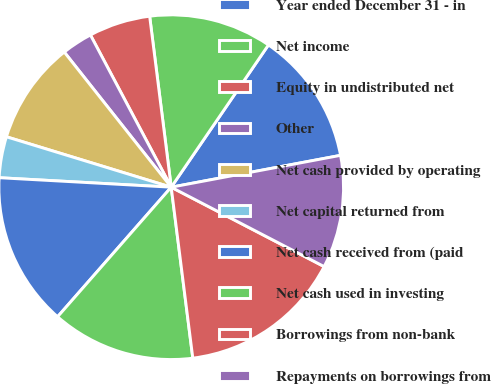Convert chart. <chart><loc_0><loc_0><loc_500><loc_500><pie_chart><fcel>Year ended December 31 - in<fcel>Net income<fcel>Equity in undistributed net<fcel>Other<fcel>Net cash provided by operating<fcel>Net capital returned from<fcel>Net cash received from (paid<fcel>Net cash used in investing<fcel>Borrowings from non-bank<fcel>Repayments on borrowings from<nl><fcel>12.5%<fcel>11.54%<fcel>5.77%<fcel>2.89%<fcel>9.62%<fcel>3.85%<fcel>14.42%<fcel>13.46%<fcel>15.38%<fcel>10.58%<nl></chart> 